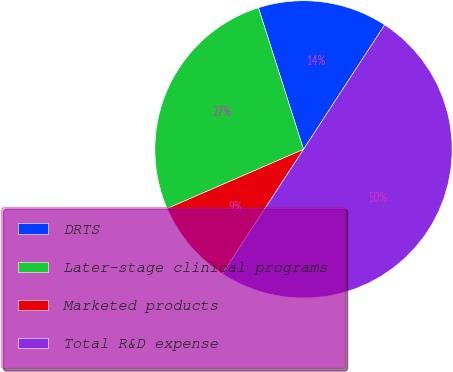Convert chart. <chart><loc_0><loc_0><loc_500><loc_500><pie_chart><fcel>DRTS<fcel>Later-stage clinical programs<fcel>Marketed products<fcel>Total R&D expense<nl><fcel>14.1%<fcel>26.61%<fcel>9.29%<fcel>50.0%<nl></chart> 